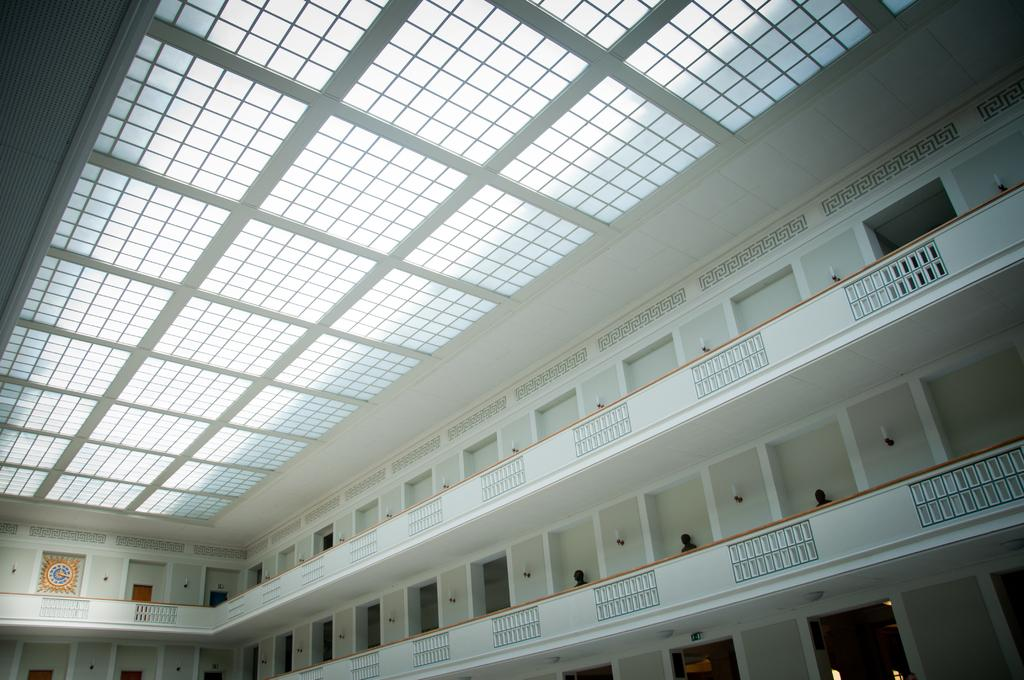What type of view is shown in the image? The image shows an inner view of a building. What architectural features can be seen in the image? There are doors and walls visible in the image. How many girls are present in the image? There are no girls present in the image; it only shows an inner view of a building with doors and walls. 